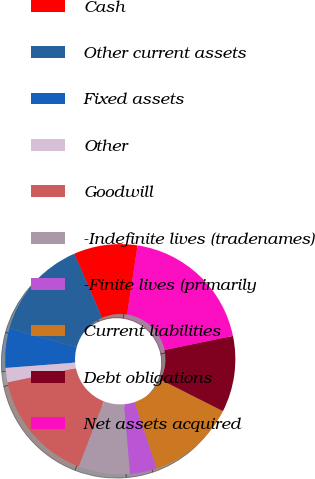Convert chart. <chart><loc_0><loc_0><loc_500><loc_500><pie_chart><fcel>Cash<fcel>Other current assets<fcel>Fixed assets<fcel>Other<fcel>Goodwill<fcel>-Indefinite lives (tradenames)<fcel>-Finite lives (primarily<fcel>Current liabilities<fcel>Debt obligations<fcel>Net assets acquired<nl><fcel>8.96%<fcel>14.16%<fcel>5.5%<fcel>2.03%<fcel>15.89%<fcel>7.23%<fcel>3.77%<fcel>12.42%<fcel>10.69%<fcel>19.35%<nl></chart> 